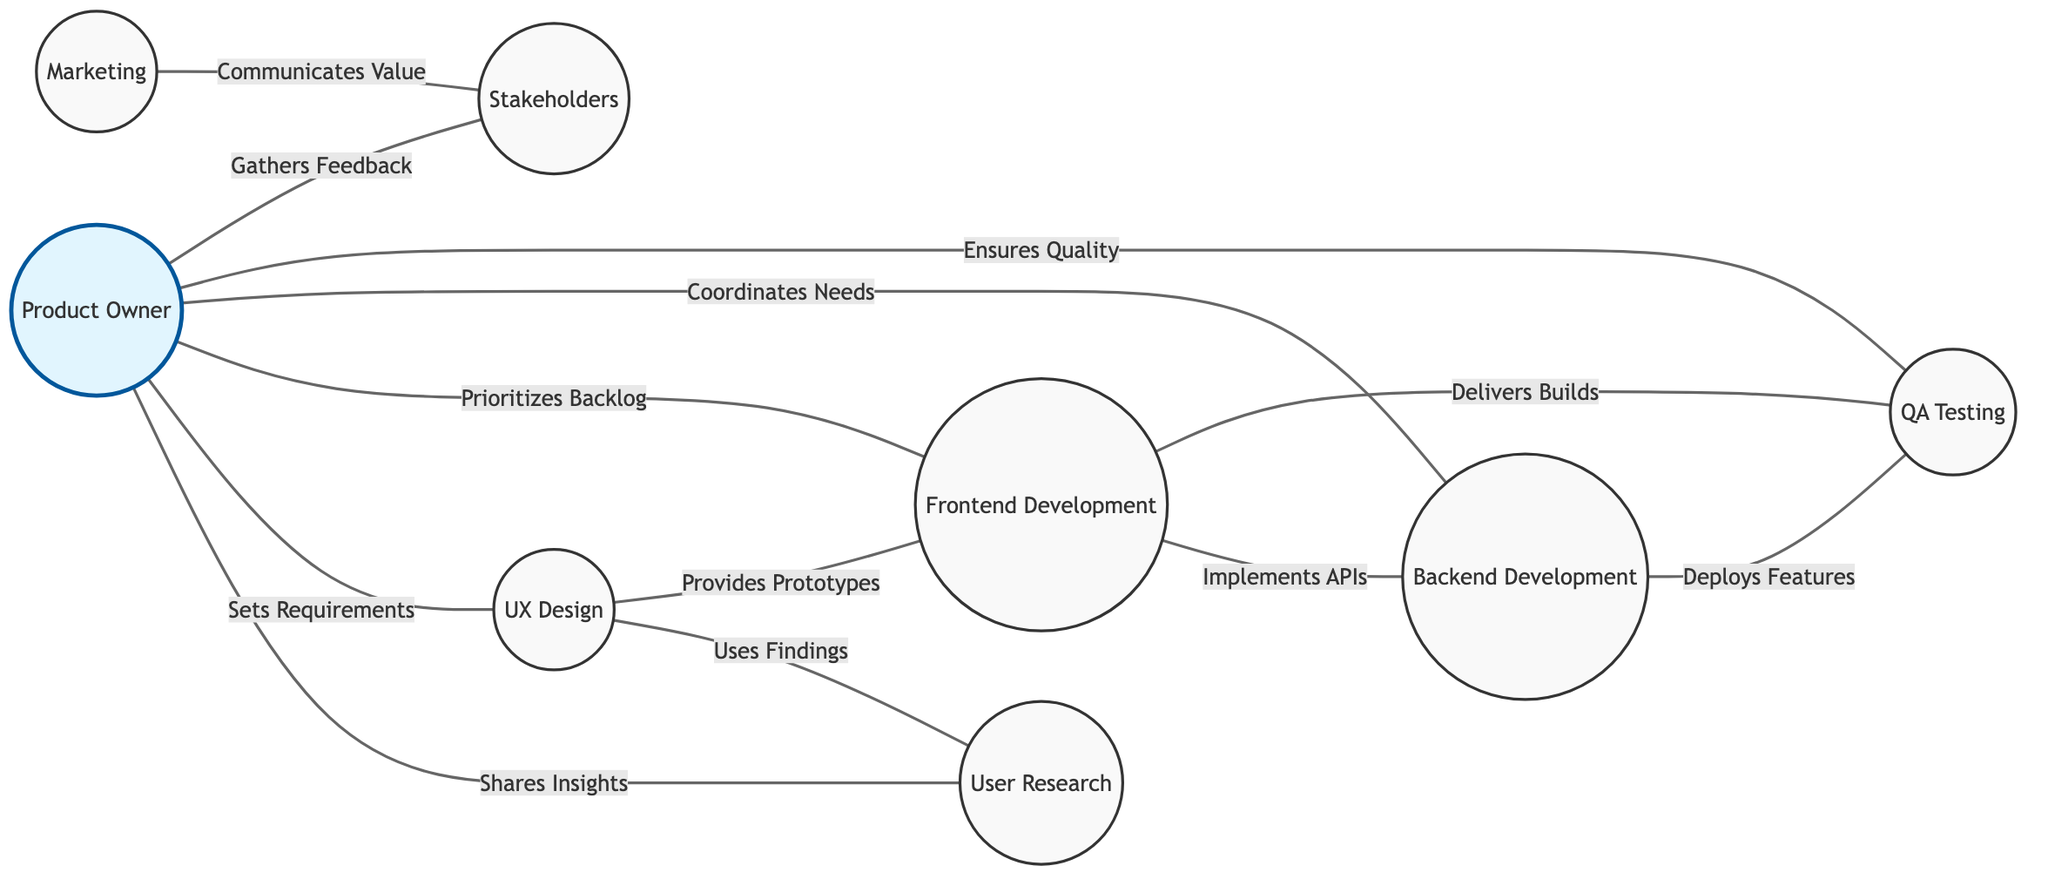What is the total number of nodes in the diagram? The diagram contains a list of nodes including User Research, Product Owner, UX Design, Frontend Development, Backend Development, QA Testing, Marketing, and Stakeholders. Counting these gives a total of eight distinct nodes.
Answer: 8 Who does the Product Owner share insights with? The diagram shows a direct connection between the Product Owner and User Research labeled "Shares Insights". Therefore, the Product Owner shares insights specifically with User Research.
Answer: User Research How many connections does the Frontend Development node have? The Frontend Development node is connected to Backend Development, QA Testing, and UX Design, representing three relationships. Thus, there are three edges connected to the Frontend Development node.
Answer: 3 What role is responsible for gathering feedback from stakeholders? The connection labeled "Gathers Feedback" indicates that the Product Owner is the role responsible for this activity, as it connects directly to Stakeholders.
Answer: Product Owner Which node is linked to both Marketing and QA Testing? The analysis of the edges and connections shows that Marketing is only connected to Stakeholders, while QA Testing directly connects with Frontend Development and Backend Development but not Marketing. Thus, there is no single node that connects to both directly. Therefore, the answer is that no node connects to both.
Answer: None What relationship exists between UX Design and User Research? The diagram shows a connection between the two nodes labeled "Uses Findings". This indicates that UX Design relies on User Research for its insights.
Answer: Uses Findings Which two nodes have a direct link through "Implements APIs"? The edge labeled "Implements APIs" connects Frontend Development to Backend Development, indicating a partnership in API implementation between these two roles.
Answer: Frontend Development and Backend Development How many edges are present in the diagram? By counting all connections or edges drawn between the various nodes in the diagram, we find there are 12 lines of connection displayed, indicating the number of edges.
Answer: 12 What is the purpose of the Product Owner in the development process? The Product Owner manages several connections, such as setting requirements for UX Design, prioritizing the backlog for Frontend Development, and ensuring quality with QA Testing. Thus, their purpose is centralized around guiding the development process towards meeting user needs and quality assurance.
Answer: Central role in development process 